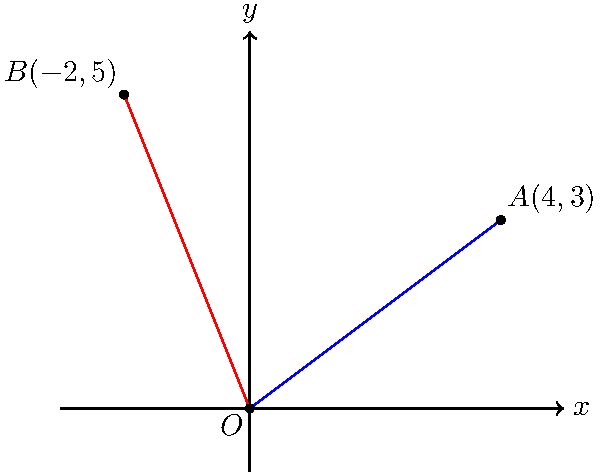In the given coordinate system, two lines OA and OB are drawn from the origin O to points A(4,3) and B(-2,5) respectively. Calculate the angle between these two lines in degrees, rounded to the nearest whole number. To find the angle between two lines in a coordinate system, we can use the dot product formula:

$$\cos \theta = \frac{\vec{a} \cdot \vec{b}}{|\vec{a}||\vec{b}|}$$

Where $\vec{a}$ and $\vec{b}$ are the vectors representing the two lines, and $\theta$ is the angle between them.

Step 1: Identify the vectors
$\vec{OA} = (4,3)$
$\vec{OB} = (-2,5)$

Step 2: Calculate the dot product $\vec{a} \cdot \vec{b}$
$\vec{OA} \cdot \vec{OB} = (4)(-2) + (3)(5) = -8 + 15 = 7$

Step 3: Calculate the magnitudes of the vectors
$|\vec{OA}| = \sqrt{4^2 + 3^2} = \sqrt{16 + 9} = \sqrt{25} = 5$
$|\vec{OB}| = \sqrt{(-2)^2 + 5^2} = \sqrt{4 + 25} = \sqrt{29}$

Step 4: Apply the dot product formula
$$\cos \theta = \frac{7}{5\sqrt{29}}$$

Step 5: Take the inverse cosine (arccos) of both sides
$$\theta = \arccos(\frac{7}{5\sqrt{29}})$$

Step 6: Convert to degrees and round to the nearest whole number
$$\theta \approx 74^\circ$$
Answer: 74° 